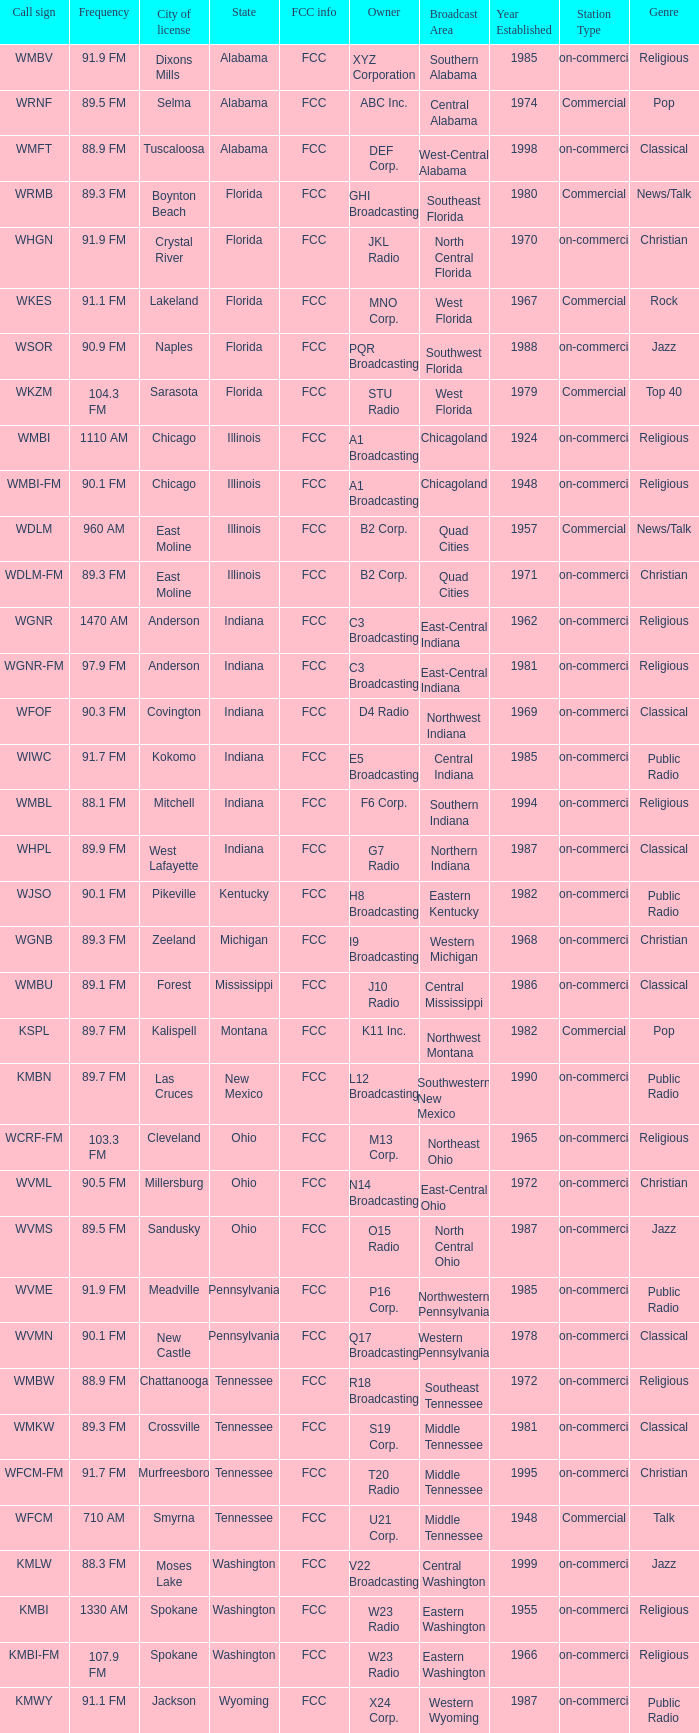What is the call sign for 90.9 FM which is in Florida? WSOR. 